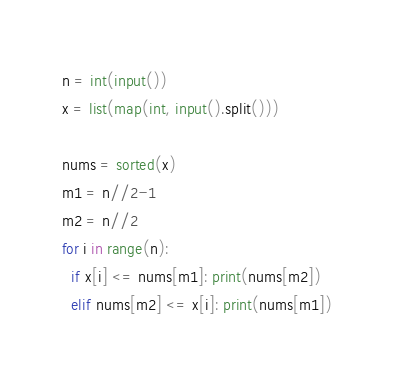<code> <loc_0><loc_0><loc_500><loc_500><_Python_>n = int(input())
x = list(map(int, input().split()))

nums = sorted(x)
m1 = n//2-1
m2 = n//2
for i in range(n):
  if x[i] <= nums[m1]: print(nums[m2])
  elif nums[m2] <= x[i]: print(nums[m1])</code> 